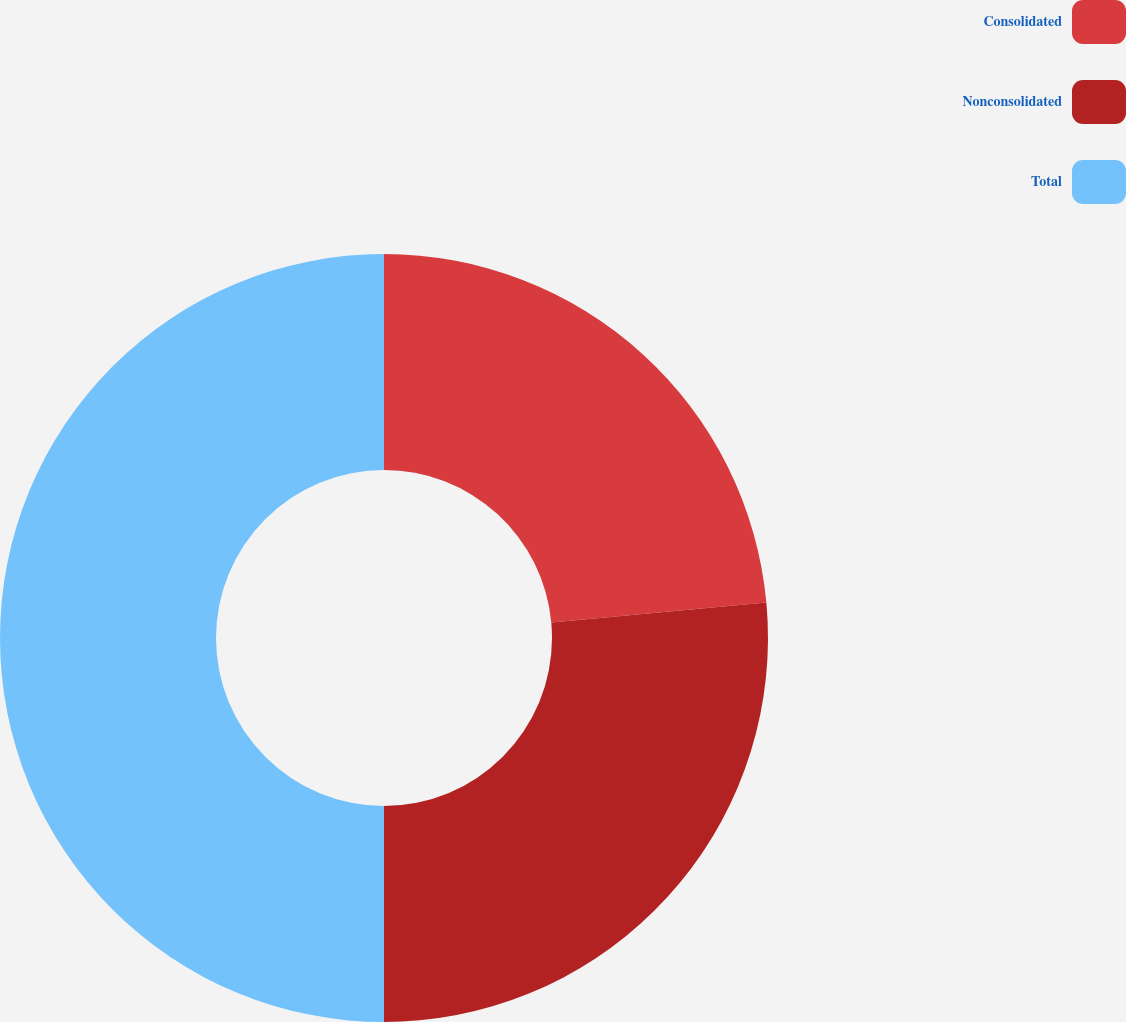Convert chart to OTSL. <chart><loc_0><loc_0><loc_500><loc_500><pie_chart><fcel>Consolidated<fcel>Nonconsolidated<fcel>Total<nl><fcel>23.53%<fcel>26.47%<fcel>50.0%<nl></chart> 